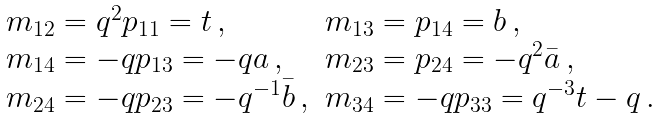<formula> <loc_0><loc_0><loc_500><loc_500>\begin{array} { l l } m _ { 1 2 } = q ^ { 2 } p _ { 1 1 } = t \, , & m _ { 1 3 } = p _ { 1 4 } = b \, , \\ m _ { 1 4 } = - q p _ { 1 3 } = - q a \, , & m _ { 2 3 } = p _ { 2 4 } = - q ^ { 2 } \bar { a } \, , \\ m _ { 2 4 } = - q p _ { 2 3 } = - q ^ { - 1 } \bar { b } \, , & m _ { 3 4 } = - q p _ { 3 3 } = q ^ { - 3 } t - q \, . \end{array}</formula> 